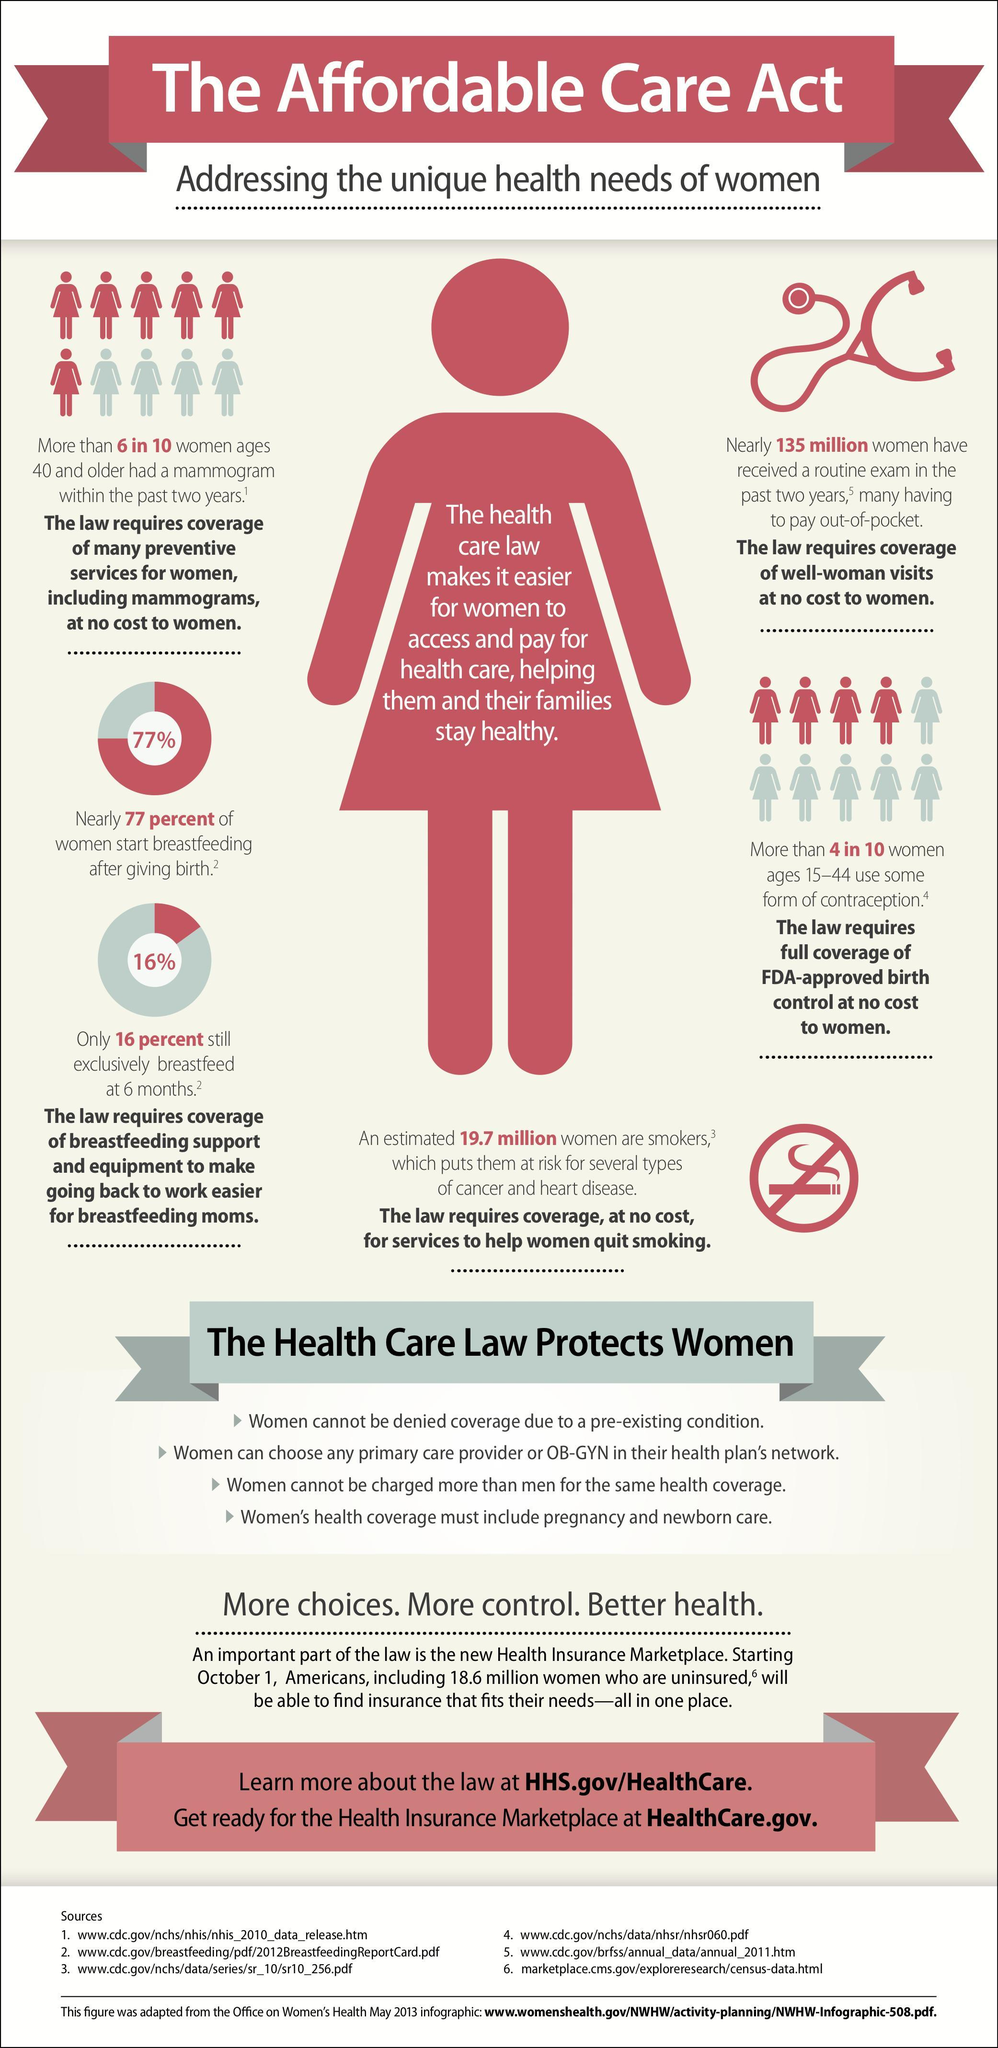What percentage of women not started breastfeeding after giving birth?
Answer the question with a short phrase. 23% 